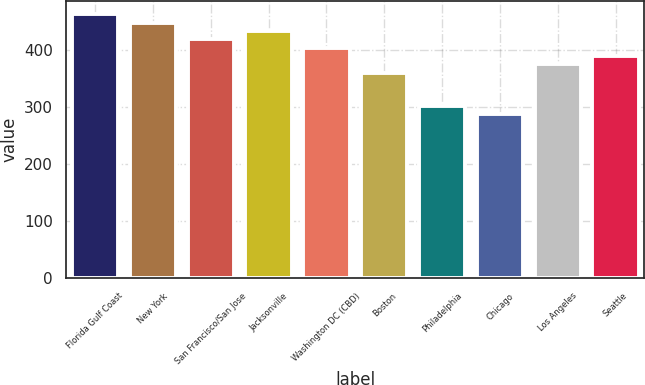<chart> <loc_0><loc_0><loc_500><loc_500><bar_chart><fcel>Florida Gulf Coast<fcel>New York<fcel>San Francisco/San Jose<fcel>Jacksonville<fcel>Washington DC (CBD)<fcel>Boston<fcel>Philadelphia<fcel>Chicago<fcel>Los Angeles<fcel>Seattle<nl><fcel>462.97<fcel>448.39<fcel>419.23<fcel>433.81<fcel>404.65<fcel>360.91<fcel>302.59<fcel>288.01<fcel>375.49<fcel>390.07<nl></chart> 